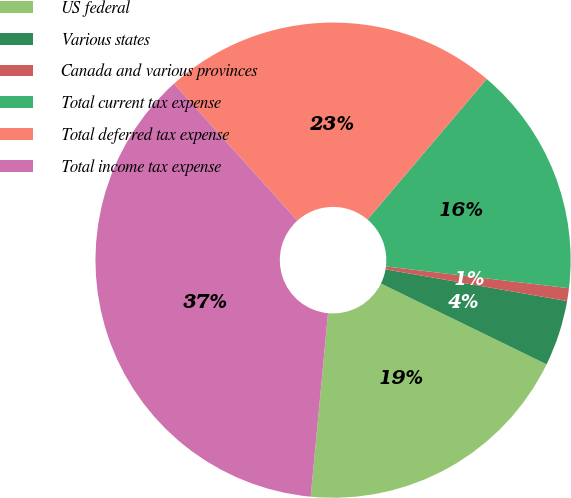<chart> <loc_0><loc_0><loc_500><loc_500><pie_chart><fcel>US federal<fcel>Various states<fcel>Canada and various provinces<fcel>Total current tax expense<fcel>Total deferred tax expense<fcel>Total income tax expense<nl><fcel>19.28%<fcel>4.47%<fcel>0.87%<fcel>15.69%<fcel>22.88%<fcel>36.82%<nl></chart> 